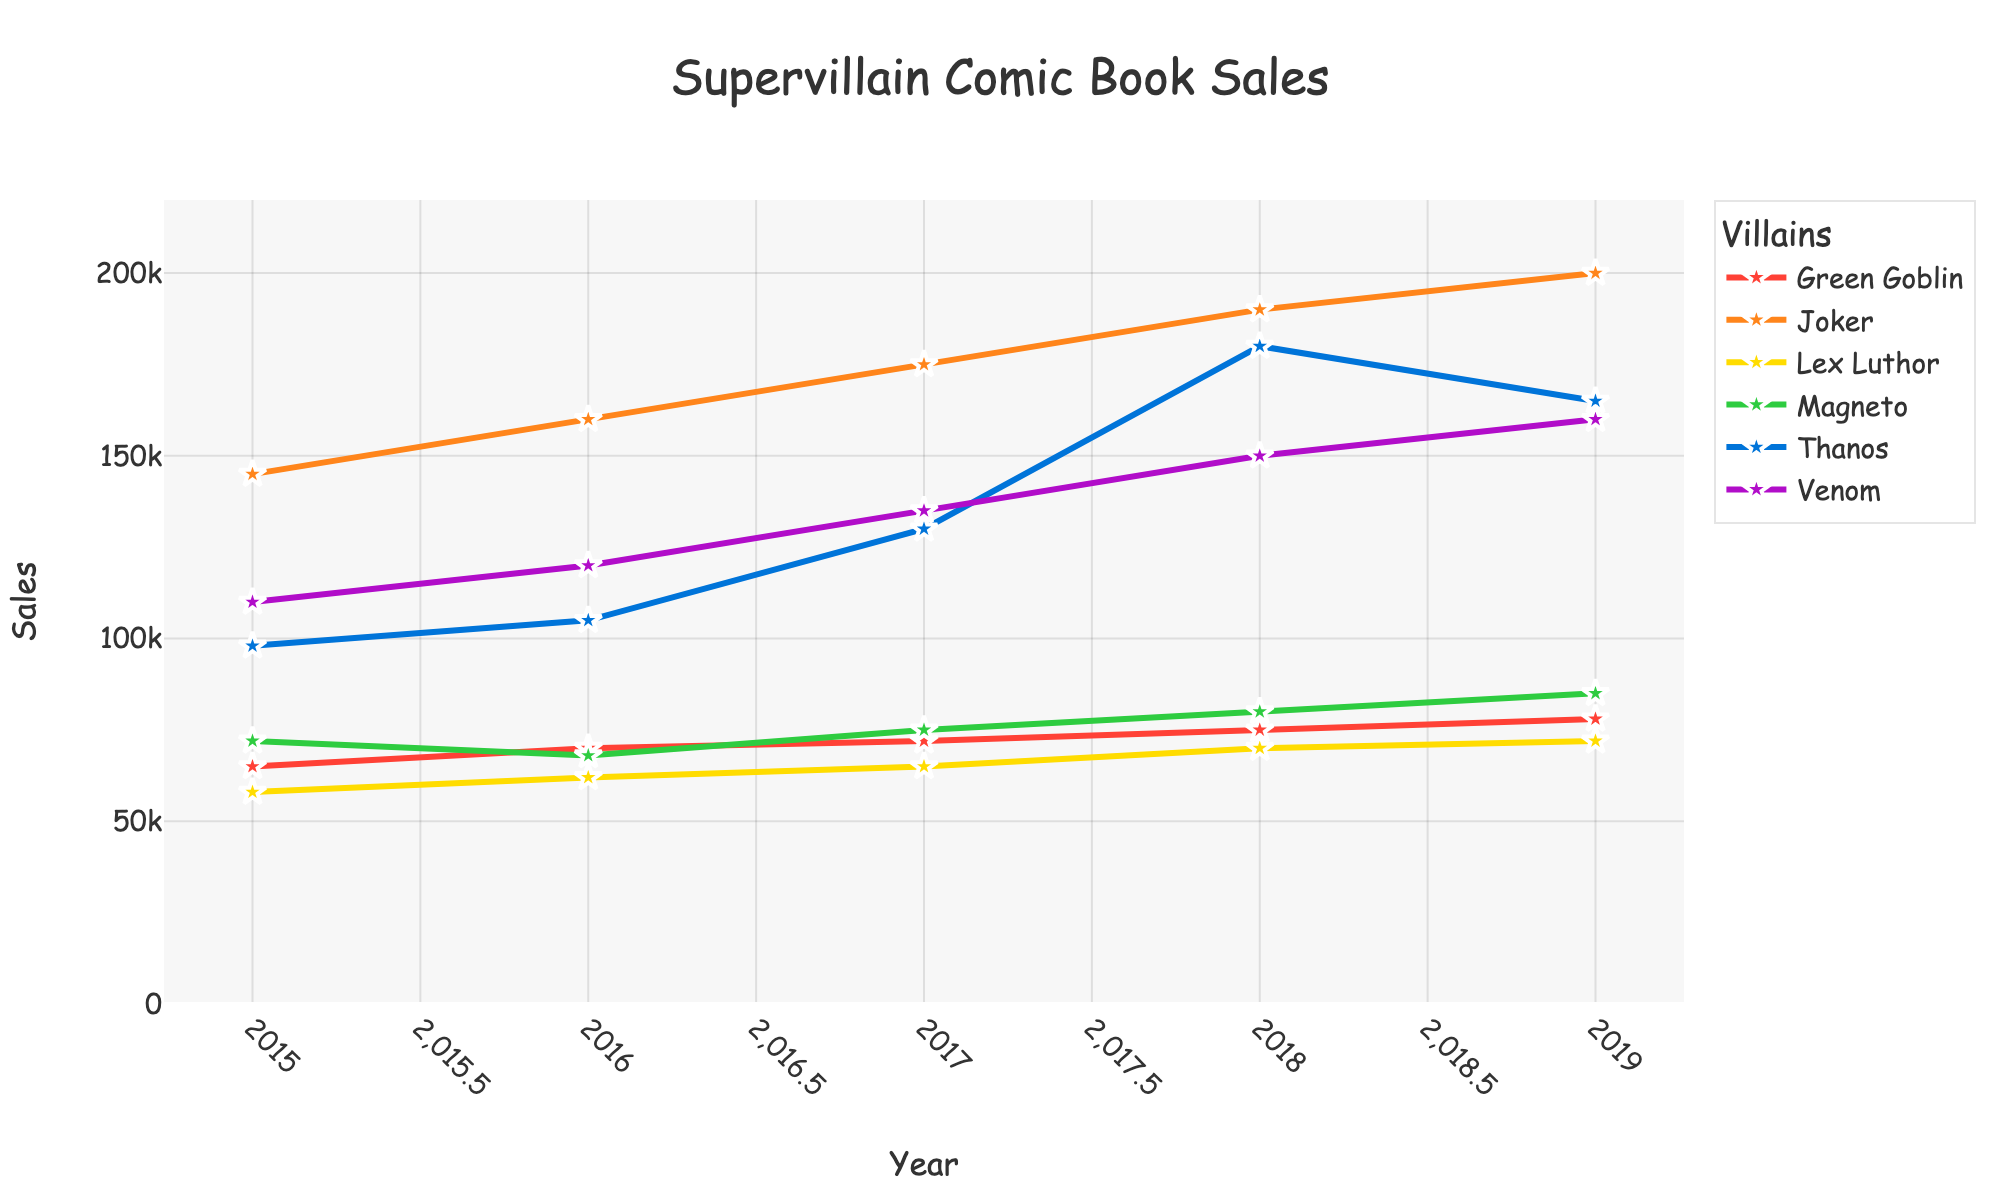What is the title of the plot? The title is written at the top of the plot, centered, and says "Supervillain Comic Book Sales".
Answer: Supervillain Comic Book Sales Which supervillain had the highest sales in 2019? Look at the 2019 data points and compare the heights of the lines. The tallest line for 2019 belongs to Joker, which means he had the highest sales.
Answer: Joker What is the color of the line representing Thanos? Each supervillain is represented with a different color. Thanos’ line is the second one, which is orange.
Answer: Orange What is the trend of sales for Joker from 2015 to 2019? Joker's sales are consistently increasing from 145,000 in 2015 to 200,000 in 2019.
Answer: Increasing How many years are covered in this plot? The x-axis shows the years, which range from 2015 to 2019, so there are 5 years covered.
Answer: 5 Between which two years did Venom's sales increase the most? Compare the differences in Venom's sales each year. The biggest jump is between 2017 and 2018, from 135,000 to 150,000.
Answer: 2017 and 2018 Who had the lowest sales in 2015 and what was it? Look at the 2015 data points and find the lowest one, which belongs to Lex Luthor with 58,000.
Answer: Lex Luthor, 58,000 Compare Joker's sales in 2016 and Thanos' sales in 2017. Which one was higher? Find Joker's sales for 2016 (160,000) and Thanos' sales for 2017 (130,000). Since 160,000 is higher than 130,000, Joker's sales in 2016 were higher.
Answer: Joker What is the average sales figure for Green Goblin from 2015 to 2019? Find Green Goblin's sales for each year (65,000, 70,000, 72,000, 75,000, 78,000), sum them (360,000) and divide by 5 (number of years), which equals 72,000.
Answer: 72,000 What trend do you observe for Magneto’s sales from 2015 to 2019? Magneto's sales have a slightly increasing trend with moderate fluctuations, starting from 72,000 in 2015 and ending at 85,000 in 2019.
Answer: Slightly increasing 